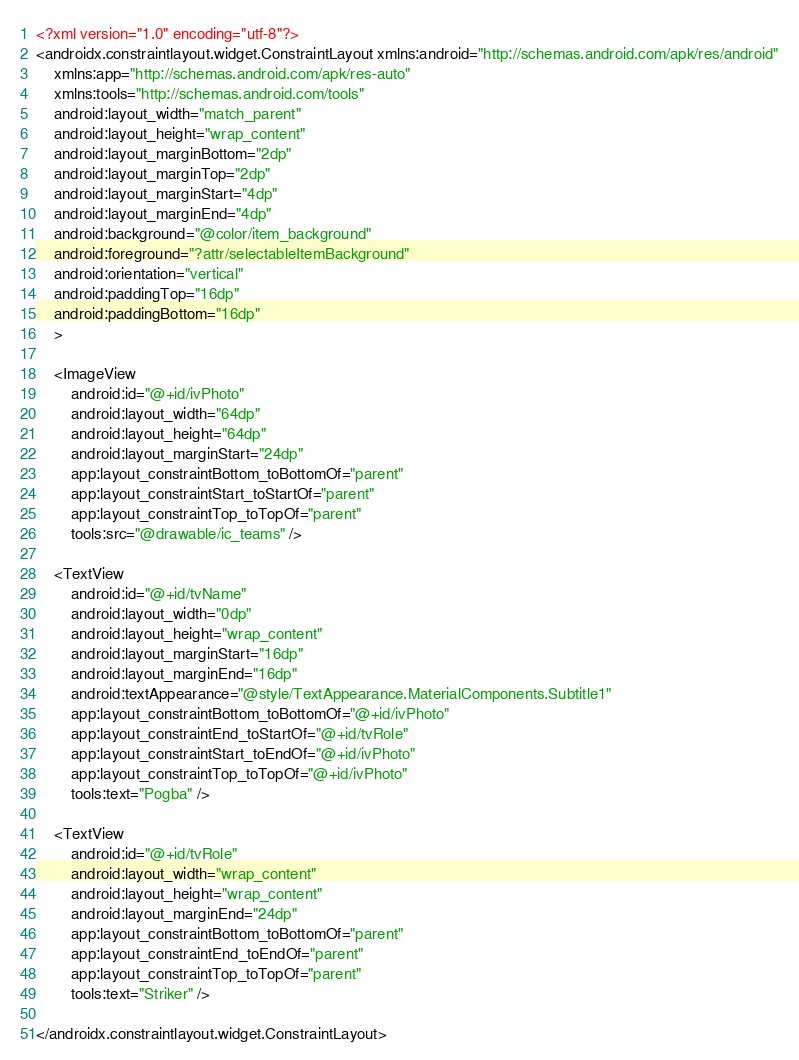<code> <loc_0><loc_0><loc_500><loc_500><_XML_><?xml version="1.0" encoding="utf-8"?>
<androidx.constraintlayout.widget.ConstraintLayout xmlns:android="http://schemas.android.com/apk/res/android"
    xmlns:app="http://schemas.android.com/apk/res-auto"
    xmlns:tools="http://schemas.android.com/tools"
    android:layout_width="match_parent"
    android:layout_height="wrap_content"
    android:layout_marginBottom="2dp"
    android:layout_marginTop="2dp"
    android:layout_marginStart="4dp"
    android:layout_marginEnd="4dp"
    android:background="@color/item_background"
    android:foreground="?attr/selectableItemBackground"
    android:orientation="vertical"
    android:paddingTop="16dp"
    android:paddingBottom="16dp"
    >

    <ImageView
        android:id="@+id/ivPhoto"
        android:layout_width="64dp"
        android:layout_height="64dp"
        android:layout_marginStart="24dp"
        app:layout_constraintBottom_toBottomOf="parent"
        app:layout_constraintStart_toStartOf="parent"
        app:layout_constraintTop_toTopOf="parent"
        tools:src="@drawable/ic_teams" />

    <TextView
        android:id="@+id/tvName"
        android:layout_width="0dp"
        android:layout_height="wrap_content"
        android:layout_marginStart="16dp"
        android:layout_marginEnd="16dp"
        android:textAppearance="@style/TextAppearance.MaterialComponents.Subtitle1"
        app:layout_constraintBottom_toBottomOf="@+id/ivPhoto"
        app:layout_constraintEnd_toStartOf="@+id/tvRole"
        app:layout_constraintStart_toEndOf="@+id/ivPhoto"
        app:layout_constraintTop_toTopOf="@+id/ivPhoto"
        tools:text="Pogba" />

    <TextView
        android:id="@+id/tvRole"
        android:layout_width="wrap_content"
        android:layout_height="wrap_content"
        android:layout_marginEnd="24dp"
        app:layout_constraintBottom_toBottomOf="parent"
        app:layout_constraintEnd_toEndOf="parent"
        app:layout_constraintTop_toTopOf="parent"
        tools:text="Striker" />

</androidx.constraintlayout.widget.ConstraintLayout></code> 